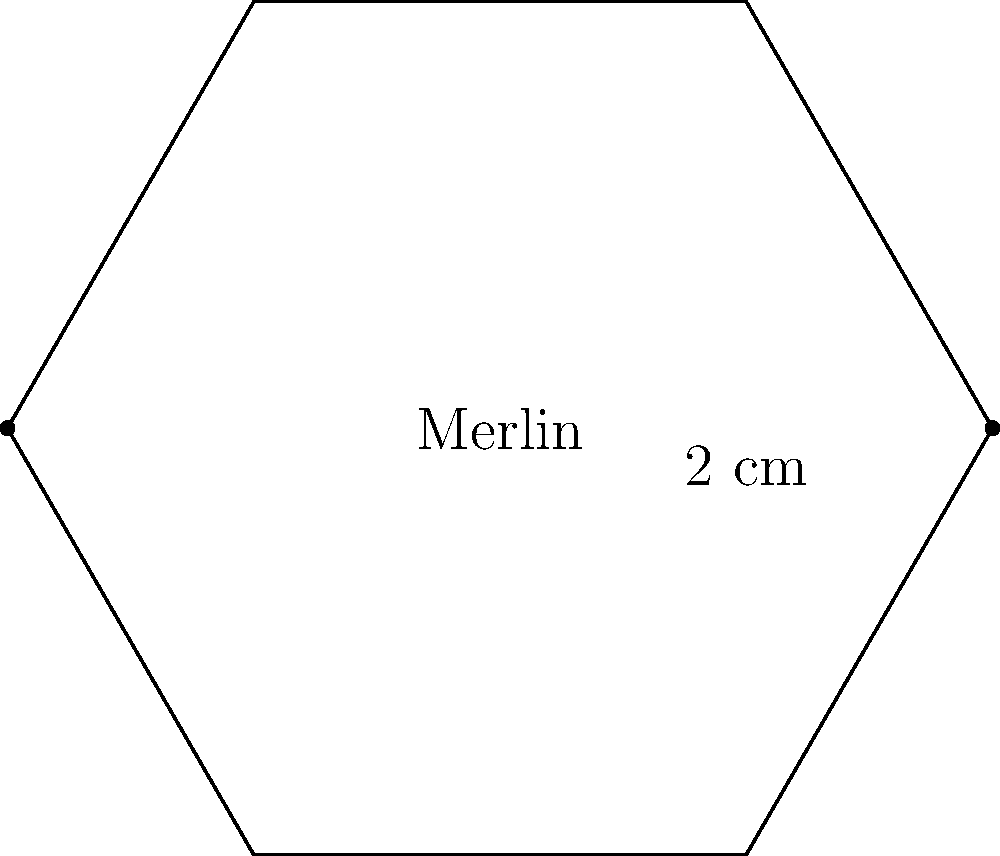You've just found a rare Merlin hexagonal football sticker from the '90s. The sticker measures 2 cm on each side. What is the perimeter of this collectible sticker? Let's approach this step-by-step:

1) First, recall that a hexagon has 6 sides.

2) We're given that each side of the hexagon measures 2 cm.

3) To find the perimeter, we need to sum up the lengths of all sides.

4) Since all sides are equal, we can multiply the length of one side by the number of sides:

   $$ \text{Perimeter} = 6 \times 2 \text{ cm} $$

5) Calculating:

   $$ \text{Perimeter} = 12 \text{ cm} $$

Therefore, the perimeter of the hexagonal Merlin football sticker is 12 cm.
Answer: 12 cm 